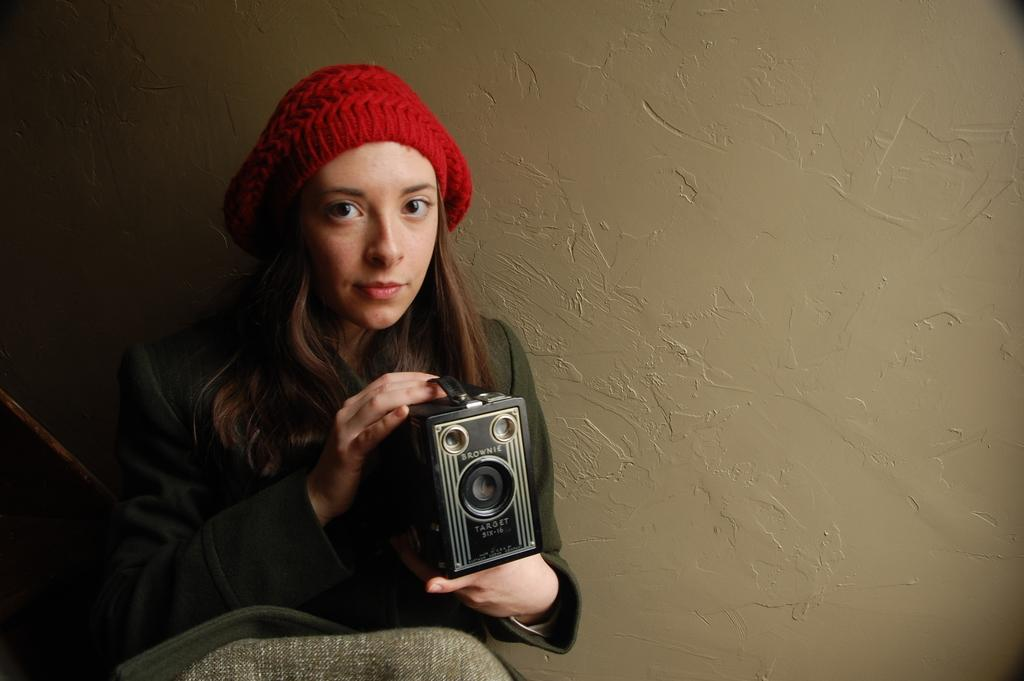What is the main subject of the image? The main subject of the image is a lady. What is the lady holding in the image? The lady is holding a vintage camera. Can you describe the lady's attire in the image? The lady is wearing a black cap on her head. What type of crime is being committed in the image? There is no crime being committed in the image; it features a lady holding a vintage camera. What type of beef dish is being prepared in the image? There is no beef dish or any food preparation visible in the image. 